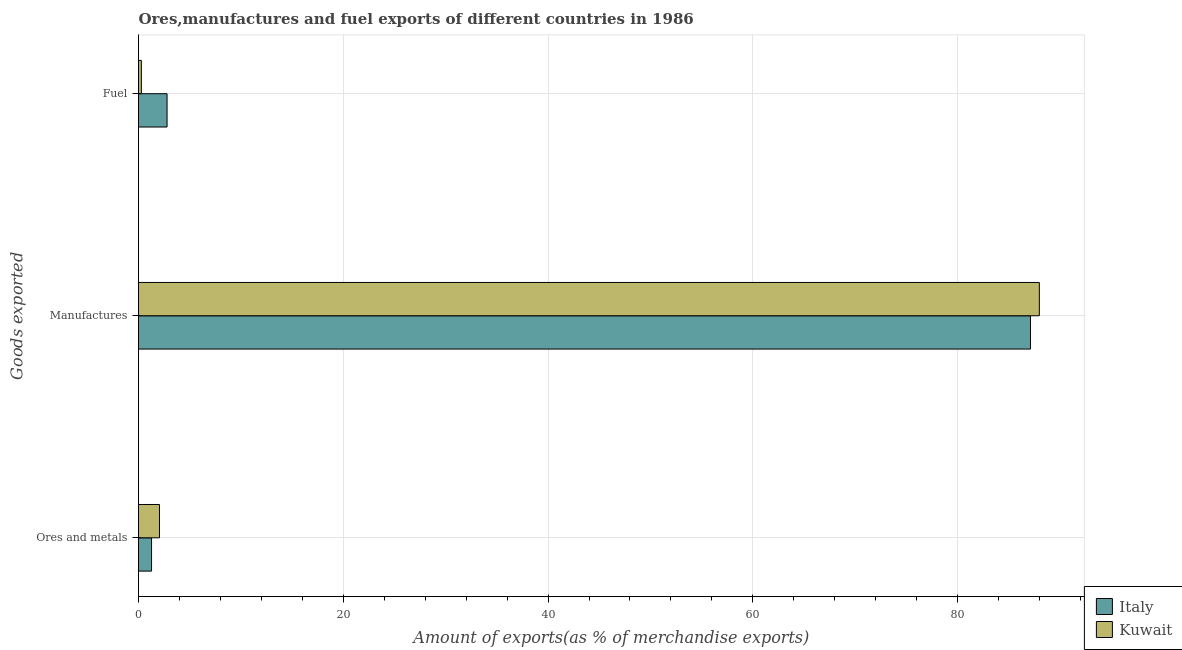How many different coloured bars are there?
Give a very brief answer. 2. Are the number of bars per tick equal to the number of legend labels?
Make the answer very short. Yes. How many bars are there on the 1st tick from the bottom?
Offer a very short reply. 2. What is the label of the 1st group of bars from the top?
Your answer should be compact. Fuel. What is the percentage of fuel exports in Italy?
Your answer should be compact. 2.79. Across all countries, what is the maximum percentage of fuel exports?
Provide a short and direct response. 2.79. Across all countries, what is the minimum percentage of manufactures exports?
Offer a terse response. 87.12. In which country was the percentage of manufactures exports maximum?
Provide a succinct answer. Kuwait. In which country was the percentage of manufactures exports minimum?
Give a very brief answer. Italy. What is the total percentage of manufactures exports in the graph?
Provide a short and direct response. 175.1. What is the difference between the percentage of manufactures exports in Kuwait and that in Italy?
Your response must be concise. 0.87. What is the difference between the percentage of manufactures exports in Italy and the percentage of fuel exports in Kuwait?
Your response must be concise. 86.84. What is the average percentage of fuel exports per country?
Provide a short and direct response. 1.53. What is the difference between the percentage of manufactures exports and percentage of fuel exports in Kuwait?
Make the answer very short. 87.7. What is the ratio of the percentage of fuel exports in Kuwait to that in Italy?
Your answer should be very brief. 0.1. Is the difference between the percentage of fuel exports in Kuwait and Italy greater than the difference between the percentage of manufactures exports in Kuwait and Italy?
Offer a terse response. No. What is the difference between the highest and the second highest percentage of manufactures exports?
Make the answer very short. 0.87. What is the difference between the highest and the lowest percentage of fuel exports?
Your answer should be compact. 2.51. In how many countries, is the percentage of ores and metals exports greater than the average percentage of ores and metals exports taken over all countries?
Keep it short and to the point. 1. What does the 1st bar from the top in Manufactures represents?
Offer a terse response. Kuwait. What does the 1st bar from the bottom in Manufactures represents?
Offer a very short reply. Italy. Is it the case that in every country, the sum of the percentage of ores and metals exports and percentage of manufactures exports is greater than the percentage of fuel exports?
Offer a very short reply. Yes. How many bars are there?
Provide a short and direct response. 6. How many countries are there in the graph?
Your answer should be compact. 2. What is the difference between two consecutive major ticks on the X-axis?
Offer a terse response. 20. Are the values on the major ticks of X-axis written in scientific E-notation?
Offer a terse response. No. Does the graph contain any zero values?
Your answer should be compact. No. What is the title of the graph?
Offer a very short reply. Ores,manufactures and fuel exports of different countries in 1986. Does "Costa Rica" appear as one of the legend labels in the graph?
Offer a terse response. No. What is the label or title of the X-axis?
Your answer should be very brief. Amount of exports(as % of merchandise exports). What is the label or title of the Y-axis?
Provide a short and direct response. Goods exported. What is the Amount of exports(as % of merchandise exports) in Italy in Ores and metals?
Offer a terse response. 1.27. What is the Amount of exports(as % of merchandise exports) of Kuwait in Ores and metals?
Your response must be concise. 2.05. What is the Amount of exports(as % of merchandise exports) of Italy in Manufactures?
Ensure brevity in your answer.  87.12. What is the Amount of exports(as % of merchandise exports) in Kuwait in Manufactures?
Give a very brief answer. 87.98. What is the Amount of exports(as % of merchandise exports) of Italy in Fuel?
Your answer should be compact. 2.79. What is the Amount of exports(as % of merchandise exports) of Kuwait in Fuel?
Your answer should be very brief. 0.28. Across all Goods exported, what is the maximum Amount of exports(as % of merchandise exports) in Italy?
Make the answer very short. 87.12. Across all Goods exported, what is the maximum Amount of exports(as % of merchandise exports) of Kuwait?
Keep it short and to the point. 87.98. Across all Goods exported, what is the minimum Amount of exports(as % of merchandise exports) in Italy?
Give a very brief answer. 1.27. Across all Goods exported, what is the minimum Amount of exports(as % of merchandise exports) in Kuwait?
Offer a very short reply. 0.28. What is the total Amount of exports(as % of merchandise exports) in Italy in the graph?
Your answer should be very brief. 91.18. What is the total Amount of exports(as % of merchandise exports) in Kuwait in the graph?
Make the answer very short. 90.31. What is the difference between the Amount of exports(as % of merchandise exports) in Italy in Ores and metals and that in Manufactures?
Give a very brief answer. -85.84. What is the difference between the Amount of exports(as % of merchandise exports) in Kuwait in Ores and metals and that in Manufactures?
Offer a terse response. -85.93. What is the difference between the Amount of exports(as % of merchandise exports) in Italy in Ores and metals and that in Fuel?
Keep it short and to the point. -1.52. What is the difference between the Amount of exports(as % of merchandise exports) in Kuwait in Ores and metals and that in Fuel?
Your response must be concise. 1.77. What is the difference between the Amount of exports(as % of merchandise exports) of Italy in Manufactures and that in Fuel?
Your answer should be very brief. 84.33. What is the difference between the Amount of exports(as % of merchandise exports) of Kuwait in Manufactures and that in Fuel?
Your response must be concise. 87.7. What is the difference between the Amount of exports(as % of merchandise exports) of Italy in Ores and metals and the Amount of exports(as % of merchandise exports) of Kuwait in Manufactures?
Give a very brief answer. -86.71. What is the difference between the Amount of exports(as % of merchandise exports) of Italy in Manufactures and the Amount of exports(as % of merchandise exports) of Kuwait in Fuel?
Keep it short and to the point. 86.84. What is the average Amount of exports(as % of merchandise exports) in Italy per Goods exported?
Offer a very short reply. 30.39. What is the average Amount of exports(as % of merchandise exports) of Kuwait per Goods exported?
Make the answer very short. 30.1. What is the difference between the Amount of exports(as % of merchandise exports) of Italy and Amount of exports(as % of merchandise exports) of Kuwait in Ores and metals?
Offer a terse response. -0.77. What is the difference between the Amount of exports(as % of merchandise exports) in Italy and Amount of exports(as % of merchandise exports) in Kuwait in Manufactures?
Your response must be concise. -0.87. What is the difference between the Amount of exports(as % of merchandise exports) in Italy and Amount of exports(as % of merchandise exports) in Kuwait in Fuel?
Ensure brevity in your answer.  2.51. What is the ratio of the Amount of exports(as % of merchandise exports) in Italy in Ores and metals to that in Manufactures?
Make the answer very short. 0.01. What is the ratio of the Amount of exports(as % of merchandise exports) in Kuwait in Ores and metals to that in Manufactures?
Ensure brevity in your answer.  0.02. What is the ratio of the Amount of exports(as % of merchandise exports) of Italy in Ores and metals to that in Fuel?
Keep it short and to the point. 0.46. What is the ratio of the Amount of exports(as % of merchandise exports) in Kuwait in Ores and metals to that in Fuel?
Give a very brief answer. 7.34. What is the ratio of the Amount of exports(as % of merchandise exports) of Italy in Manufactures to that in Fuel?
Your answer should be compact. 31.23. What is the ratio of the Amount of exports(as % of merchandise exports) of Kuwait in Manufactures to that in Fuel?
Offer a very short reply. 315.41. What is the difference between the highest and the second highest Amount of exports(as % of merchandise exports) in Italy?
Make the answer very short. 84.33. What is the difference between the highest and the second highest Amount of exports(as % of merchandise exports) of Kuwait?
Your response must be concise. 85.93. What is the difference between the highest and the lowest Amount of exports(as % of merchandise exports) of Italy?
Your answer should be compact. 85.84. What is the difference between the highest and the lowest Amount of exports(as % of merchandise exports) of Kuwait?
Ensure brevity in your answer.  87.7. 